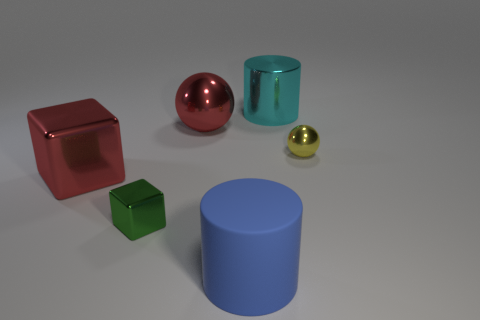Add 3 yellow things. How many objects exist? 9 Subtract all balls. How many objects are left? 4 Subtract all big rubber things. Subtract all large blue objects. How many objects are left? 4 Add 6 blue rubber cylinders. How many blue rubber cylinders are left? 7 Add 3 yellow metal cubes. How many yellow metal cubes exist? 3 Subtract 1 yellow balls. How many objects are left? 5 